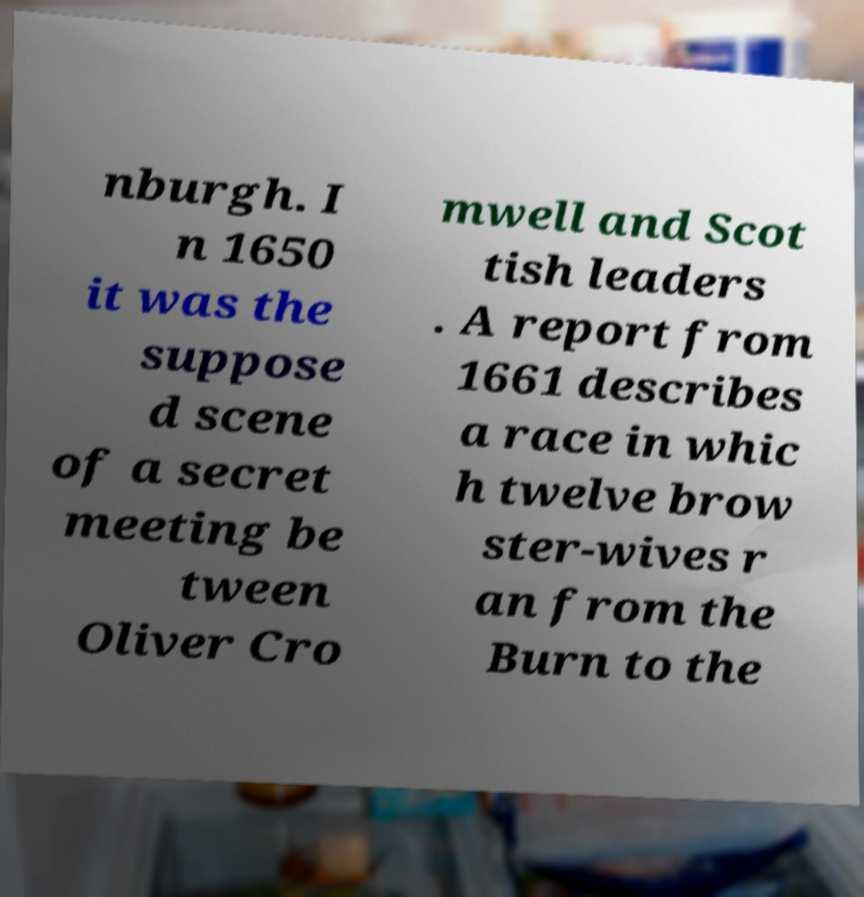What messages or text are displayed in this image? I need them in a readable, typed format. nburgh. I n 1650 it was the suppose d scene of a secret meeting be tween Oliver Cro mwell and Scot tish leaders . A report from 1661 describes a race in whic h twelve brow ster-wives r an from the Burn to the 